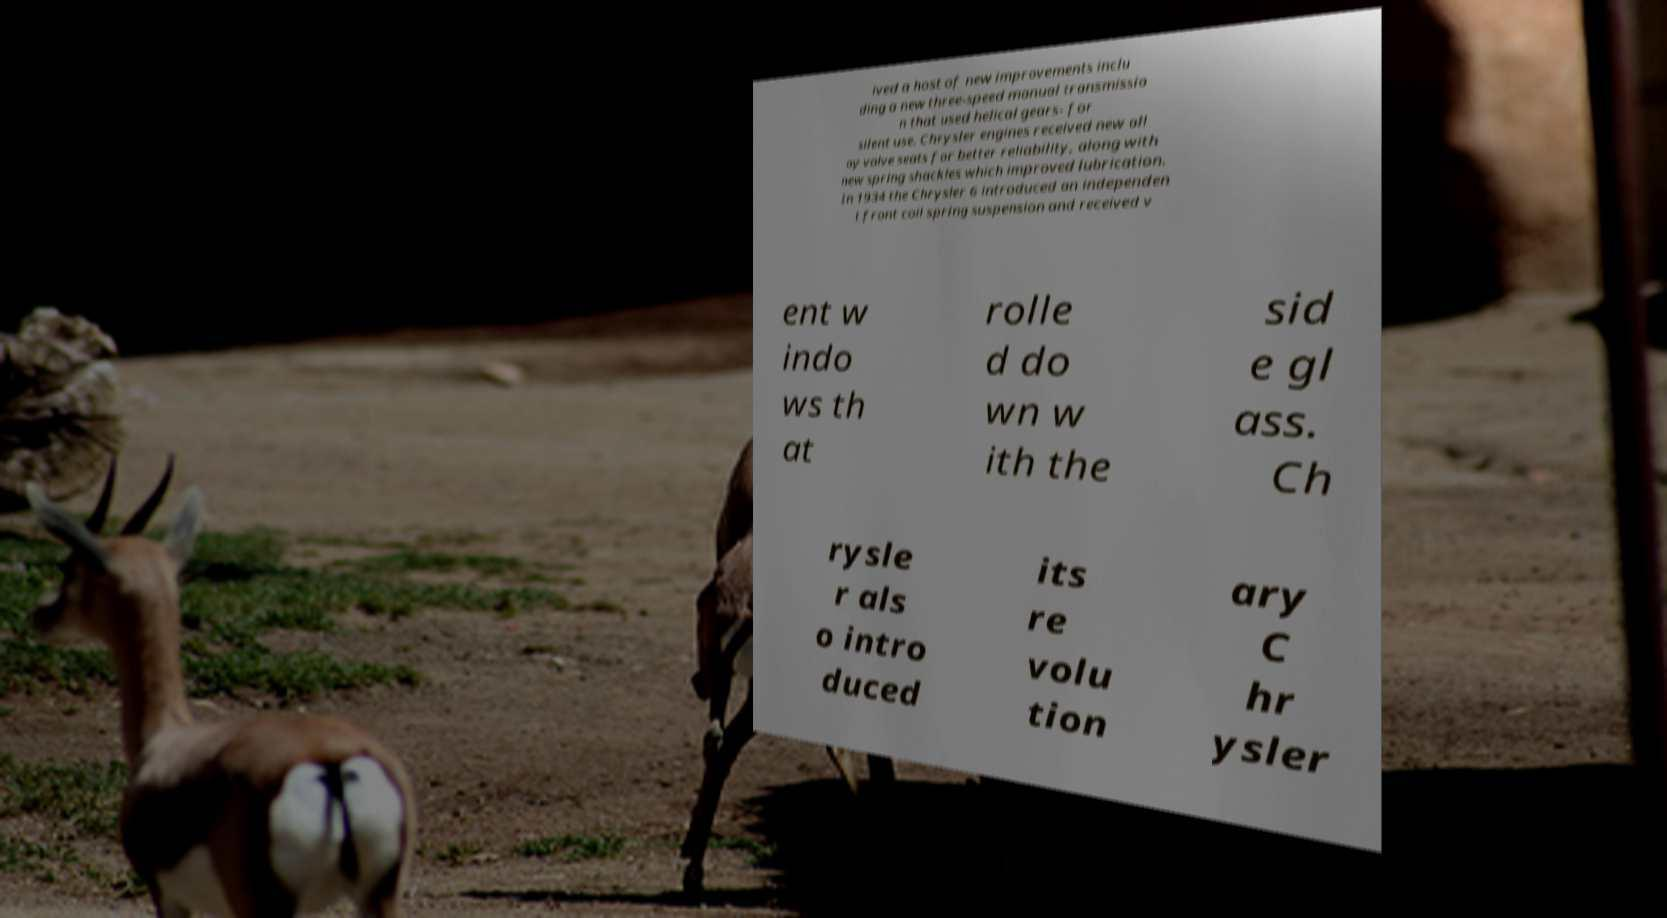Can you read and provide the text displayed in the image?This photo seems to have some interesting text. Can you extract and type it out for me? ived a host of new improvements inclu ding a new three-speed manual transmissio n that used helical gears- for silent use. Chrysler engines received new all oy valve seats for better reliability, along with new spring shackles which improved lubrication. In 1934 the Chrysler 6 introduced an independen t front coil spring suspension and received v ent w indo ws th at rolle d do wn w ith the sid e gl ass. Ch rysle r als o intro duced its re volu tion ary C hr ysler 